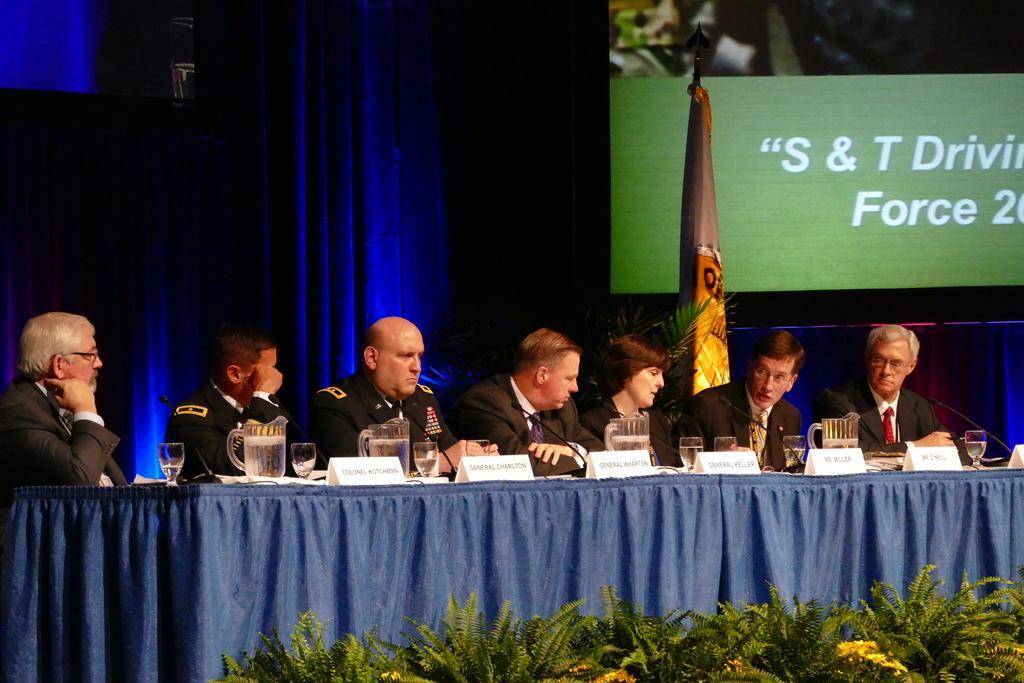Could you give a brief overview of what you see in this image? Here I can see few men sitting on the chairs in front of the table which is covered with a blue color cloth. On the table, I can see few name boards, glasses, microphones and some other objects. At the bottom there are some plants along with the flowers. In the background there is a blue color curtain. At the back of these people there is a flag. On the right side there is a screen. On the screen, I can see some text. 